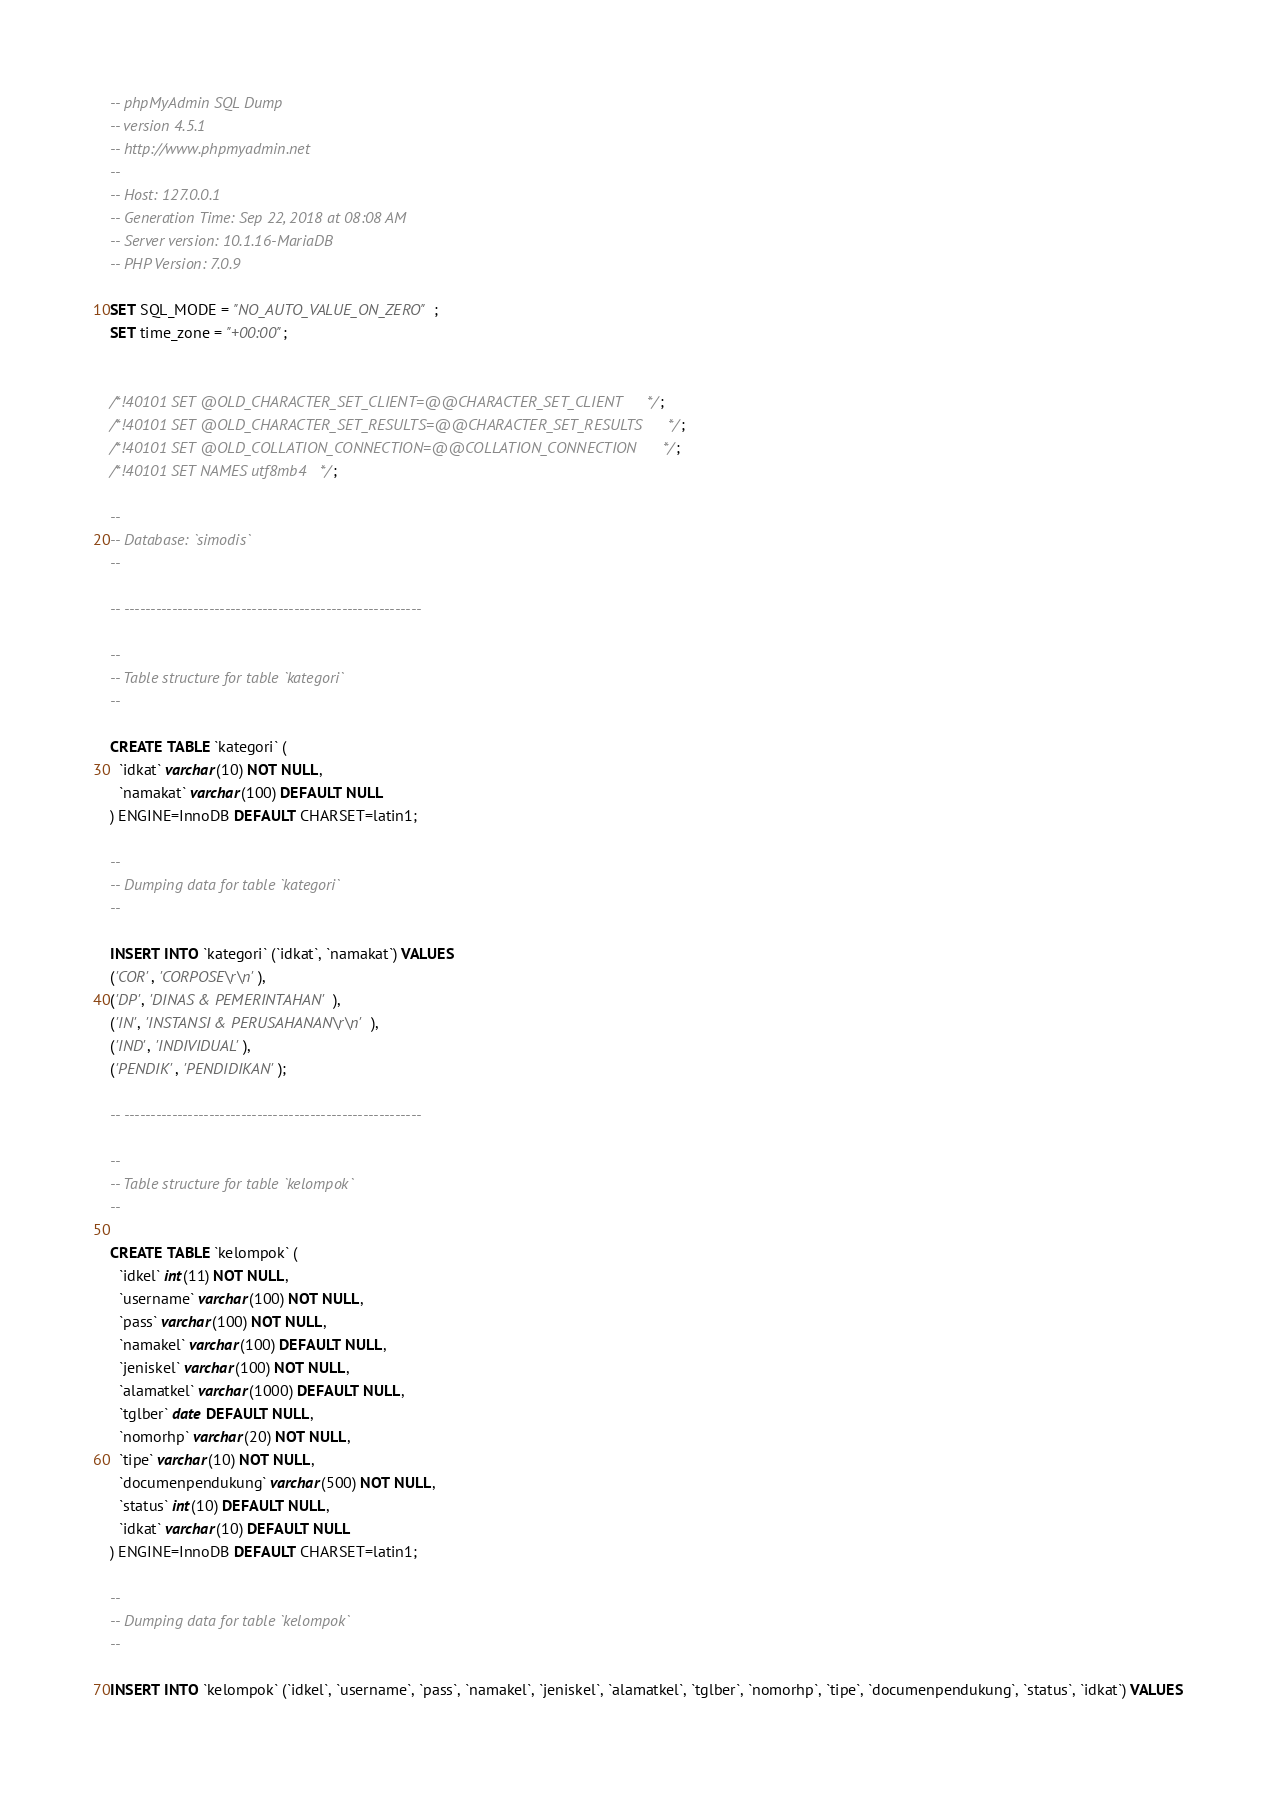<code> <loc_0><loc_0><loc_500><loc_500><_SQL_>-- phpMyAdmin SQL Dump
-- version 4.5.1
-- http://www.phpmyadmin.net
--
-- Host: 127.0.0.1
-- Generation Time: Sep 22, 2018 at 08:08 AM
-- Server version: 10.1.16-MariaDB
-- PHP Version: 7.0.9

SET SQL_MODE = "NO_AUTO_VALUE_ON_ZERO";
SET time_zone = "+00:00";


/*!40101 SET @OLD_CHARACTER_SET_CLIENT=@@CHARACTER_SET_CLIENT */;
/*!40101 SET @OLD_CHARACTER_SET_RESULTS=@@CHARACTER_SET_RESULTS */;
/*!40101 SET @OLD_COLLATION_CONNECTION=@@COLLATION_CONNECTION */;
/*!40101 SET NAMES utf8mb4 */;

--
-- Database: `simodis`
--

-- --------------------------------------------------------

--
-- Table structure for table `kategori`
--

CREATE TABLE `kategori` (
  `idkat` varchar(10) NOT NULL,
  `namakat` varchar(100) DEFAULT NULL
) ENGINE=InnoDB DEFAULT CHARSET=latin1;

--
-- Dumping data for table `kategori`
--

INSERT INTO `kategori` (`idkat`, `namakat`) VALUES
('COR', 'CORPOSE\r\n'),
('DP', 'DINAS & PEMERINTAHAN'),
('IN', 'INSTANSI & PERUSAHANAN\r\n'),
('IND', 'INDIVIDUAL'),
('PENDIK', 'PENDIDIKAN');

-- --------------------------------------------------------

--
-- Table structure for table `kelompok`
--

CREATE TABLE `kelompok` (
  `idkel` int(11) NOT NULL,
  `username` varchar(100) NOT NULL,
  `pass` varchar(100) NOT NULL,
  `namakel` varchar(100) DEFAULT NULL,
  `jeniskel` varchar(100) NOT NULL,
  `alamatkel` varchar(1000) DEFAULT NULL,
  `tglber` date DEFAULT NULL,
  `nomorhp` varchar(20) NOT NULL,
  `tipe` varchar(10) NOT NULL,
  `documenpendukung` varchar(500) NOT NULL,
  `status` int(10) DEFAULT NULL,
  `idkat` varchar(10) DEFAULT NULL
) ENGINE=InnoDB DEFAULT CHARSET=latin1;

--
-- Dumping data for table `kelompok`
--

INSERT INTO `kelompok` (`idkel`, `username`, `pass`, `namakel`, `jeniskel`, `alamatkel`, `tglber`, `nomorhp`, `tipe`, `documenpendukung`, `status`, `idkat`) VALUES</code> 